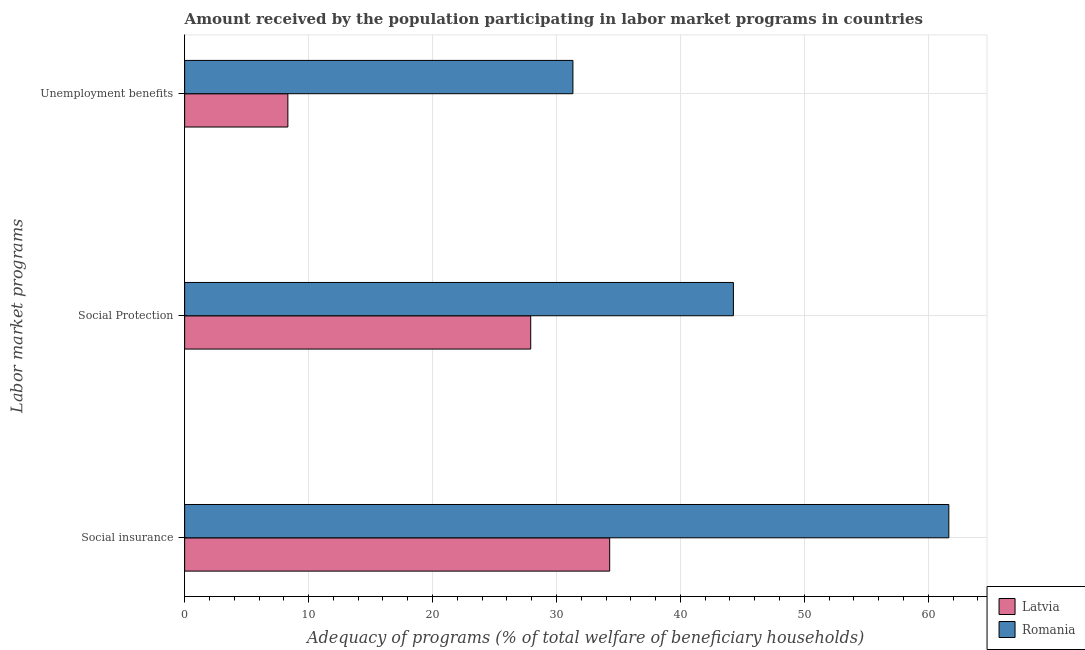Are the number of bars per tick equal to the number of legend labels?
Keep it short and to the point. Yes. Are the number of bars on each tick of the Y-axis equal?
Keep it short and to the point. Yes. What is the label of the 2nd group of bars from the top?
Keep it short and to the point. Social Protection. What is the amount received by the population participating in unemployment benefits programs in Latvia?
Provide a succinct answer. 8.33. Across all countries, what is the maximum amount received by the population participating in social insurance programs?
Provide a succinct answer. 61.66. Across all countries, what is the minimum amount received by the population participating in social protection programs?
Make the answer very short. 27.93. In which country was the amount received by the population participating in unemployment benefits programs maximum?
Give a very brief answer. Romania. In which country was the amount received by the population participating in unemployment benefits programs minimum?
Offer a terse response. Latvia. What is the total amount received by the population participating in social insurance programs in the graph?
Make the answer very short. 95.96. What is the difference between the amount received by the population participating in social insurance programs in Latvia and that in Romania?
Your response must be concise. -27.36. What is the difference between the amount received by the population participating in social protection programs in Latvia and the amount received by the population participating in social insurance programs in Romania?
Make the answer very short. -33.74. What is the average amount received by the population participating in unemployment benefits programs per country?
Your answer should be very brief. 19.83. What is the difference between the amount received by the population participating in social insurance programs and amount received by the population participating in social protection programs in Romania?
Your answer should be compact. 17.38. What is the ratio of the amount received by the population participating in social protection programs in Romania to that in Latvia?
Give a very brief answer. 1.59. What is the difference between the highest and the second highest amount received by the population participating in social protection programs?
Provide a succinct answer. 16.35. What is the difference between the highest and the lowest amount received by the population participating in social insurance programs?
Offer a very short reply. 27.36. In how many countries, is the amount received by the population participating in social protection programs greater than the average amount received by the population participating in social protection programs taken over all countries?
Your response must be concise. 1. What does the 2nd bar from the top in Unemployment benefits represents?
Provide a succinct answer. Latvia. What does the 2nd bar from the bottom in Social Protection represents?
Your answer should be compact. Romania. Are all the bars in the graph horizontal?
Ensure brevity in your answer.  Yes. How many countries are there in the graph?
Provide a short and direct response. 2. What is the difference between two consecutive major ticks on the X-axis?
Your answer should be compact. 10. Does the graph contain any zero values?
Keep it short and to the point. No. Where does the legend appear in the graph?
Offer a very short reply. Bottom right. How are the legend labels stacked?
Ensure brevity in your answer.  Vertical. What is the title of the graph?
Ensure brevity in your answer.  Amount received by the population participating in labor market programs in countries. What is the label or title of the X-axis?
Offer a terse response. Adequacy of programs (% of total welfare of beneficiary households). What is the label or title of the Y-axis?
Ensure brevity in your answer.  Labor market programs. What is the Adequacy of programs (% of total welfare of beneficiary households) in Latvia in Social insurance?
Your answer should be very brief. 34.3. What is the Adequacy of programs (% of total welfare of beneficiary households) of Romania in Social insurance?
Make the answer very short. 61.66. What is the Adequacy of programs (% of total welfare of beneficiary households) of Latvia in Social Protection?
Your answer should be compact. 27.93. What is the Adequacy of programs (% of total welfare of beneficiary households) in Romania in Social Protection?
Your answer should be compact. 44.28. What is the Adequacy of programs (% of total welfare of beneficiary households) of Latvia in Unemployment benefits?
Your response must be concise. 8.33. What is the Adequacy of programs (% of total welfare of beneficiary households) in Romania in Unemployment benefits?
Provide a succinct answer. 31.33. Across all Labor market programs, what is the maximum Adequacy of programs (% of total welfare of beneficiary households) in Latvia?
Your response must be concise. 34.3. Across all Labor market programs, what is the maximum Adequacy of programs (% of total welfare of beneficiary households) in Romania?
Offer a very short reply. 61.66. Across all Labor market programs, what is the minimum Adequacy of programs (% of total welfare of beneficiary households) of Latvia?
Provide a short and direct response. 8.33. Across all Labor market programs, what is the minimum Adequacy of programs (% of total welfare of beneficiary households) in Romania?
Ensure brevity in your answer.  31.33. What is the total Adequacy of programs (% of total welfare of beneficiary households) of Latvia in the graph?
Give a very brief answer. 70.55. What is the total Adequacy of programs (% of total welfare of beneficiary households) of Romania in the graph?
Provide a succinct answer. 137.27. What is the difference between the Adequacy of programs (% of total welfare of beneficiary households) in Latvia in Social insurance and that in Social Protection?
Offer a very short reply. 6.37. What is the difference between the Adequacy of programs (% of total welfare of beneficiary households) of Romania in Social insurance and that in Social Protection?
Your answer should be compact. 17.38. What is the difference between the Adequacy of programs (% of total welfare of beneficiary households) in Latvia in Social insurance and that in Unemployment benefits?
Give a very brief answer. 25.97. What is the difference between the Adequacy of programs (% of total welfare of beneficiary households) in Romania in Social insurance and that in Unemployment benefits?
Provide a succinct answer. 30.33. What is the difference between the Adequacy of programs (% of total welfare of beneficiary households) of Latvia in Social Protection and that in Unemployment benefits?
Give a very brief answer. 19.59. What is the difference between the Adequacy of programs (% of total welfare of beneficiary households) of Romania in Social Protection and that in Unemployment benefits?
Provide a succinct answer. 12.95. What is the difference between the Adequacy of programs (% of total welfare of beneficiary households) of Latvia in Social insurance and the Adequacy of programs (% of total welfare of beneficiary households) of Romania in Social Protection?
Your answer should be very brief. -9.98. What is the difference between the Adequacy of programs (% of total welfare of beneficiary households) in Latvia in Social insurance and the Adequacy of programs (% of total welfare of beneficiary households) in Romania in Unemployment benefits?
Your response must be concise. 2.97. What is the difference between the Adequacy of programs (% of total welfare of beneficiary households) in Latvia in Social Protection and the Adequacy of programs (% of total welfare of beneficiary households) in Romania in Unemployment benefits?
Your answer should be very brief. -3.41. What is the average Adequacy of programs (% of total welfare of beneficiary households) in Latvia per Labor market programs?
Offer a very short reply. 23.52. What is the average Adequacy of programs (% of total welfare of beneficiary households) of Romania per Labor market programs?
Offer a terse response. 45.76. What is the difference between the Adequacy of programs (% of total welfare of beneficiary households) in Latvia and Adequacy of programs (% of total welfare of beneficiary households) in Romania in Social insurance?
Give a very brief answer. -27.36. What is the difference between the Adequacy of programs (% of total welfare of beneficiary households) of Latvia and Adequacy of programs (% of total welfare of beneficiary households) of Romania in Social Protection?
Your response must be concise. -16.35. What is the difference between the Adequacy of programs (% of total welfare of beneficiary households) of Latvia and Adequacy of programs (% of total welfare of beneficiary households) of Romania in Unemployment benefits?
Offer a very short reply. -23. What is the ratio of the Adequacy of programs (% of total welfare of beneficiary households) of Latvia in Social insurance to that in Social Protection?
Keep it short and to the point. 1.23. What is the ratio of the Adequacy of programs (% of total welfare of beneficiary households) in Romania in Social insurance to that in Social Protection?
Your answer should be very brief. 1.39. What is the ratio of the Adequacy of programs (% of total welfare of beneficiary households) of Latvia in Social insurance to that in Unemployment benefits?
Offer a very short reply. 4.12. What is the ratio of the Adequacy of programs (% of total welfare of beneficiary households) in Romania in Social insurance to that in Unemployment benefits?
Give a very brief answer. 1.97. What is the ratio of the Adequacy of programs (% of total welfare of beneficiary households) in Latvia in Social Protection to that in Unemployment benefits?
Ensure brevity in your answer.  3.35. What is the ratio of the Adequacy of programs (% of total welfare of beneficiary households) in Romania in Social Protection to that in Unemployment benefits?
Ensure brevity in your answer.  1.41. What is the difference between the highest and the second highest Adequacy of programs (% of total welfare of beneficiary households) of Latvia?
Provide a short and direct response. 6.37. What is the difference between the highest and the second highest Adequacy of programs (% of total welfare of beneficiary households) of Romania?
Provide a succinct answer. 17.38. What is the difference between the highest and the lowest Adequacy of programs (% of total welfare of beneficiary households) in Latvia?
Make the answer very short. 25.97. What is the difference between the highest and the lowest Adequacy of programs (% of total welfare of beneficiary households) of Romania?
Keep it short and to the point. 30.33. 